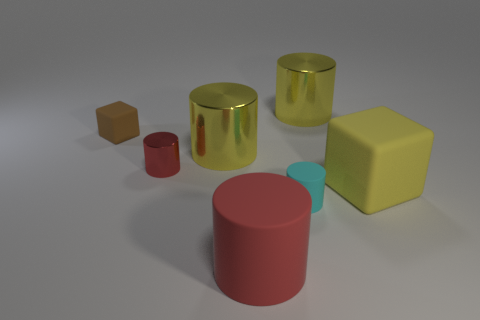Subtract all cyan cylinders. How many cylinders are left? 4 Subtract all tiny red metallic cylinders. How many cylinders are left? 4 Subtract all purple cylinders. Subtract all brown balls. How many cylinders are left? 5 Add 1 big brown matte blocks. How many objects exist? 8 Subtract all cylinders. How many objects are left? 2 Add 2 tiny shiny cylinders. How many tiny shiny cylinders are left? 3 Add 5 red shiny objects. How many red shiny objects exist? 6 Subtract 0 blue balls. How many objects are left? 7 Subtract all red cylinders. Subtract all yellow rubber things. How many objects are left? 4 